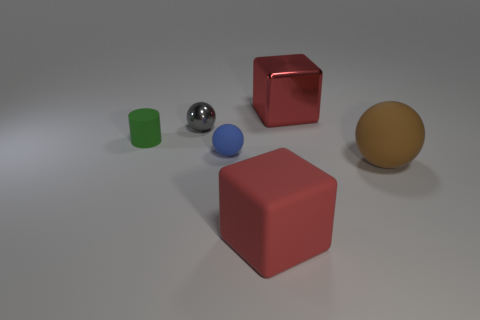What is the material of the other blue sphere that is the same size as the metallic ball?
Offer a terse response. Rubber. Are there any cyan shiny spheres that have the same size as the gray metallic object?
Ensure brevity in your answer.  No. There is a metal thing on the right side of the large rubber block; does it have the same color as the rubber object left of the tiny blue matte sphere?
Give a very brief answer. No. How many metallic objects are either large things or things?
Make the answer very short. 2. There is a big object that is left of the metallic object that is behind the small gray shiny sphere; what number of small rubber balls are on the left side of it?
Make the answer very short. 1. What size is the blue object that is the same material as the small green cylinder?
Your answer should be compact. Small. What number of tiny metallic objects are the same color as the tiny matte sphere?
Your response must be concise. 0. Is the size of the ball behind the cylinder the same as the brown rubber thing?
Make the answer very short. No. The object that is both left of the big brown rubber object and in front of the blue thing is what color?
Your answer should be compact. Red. What number of objects are large gray metallic spheres or objects left of the small gray metallic object?
Give a very brief answer. 1. 